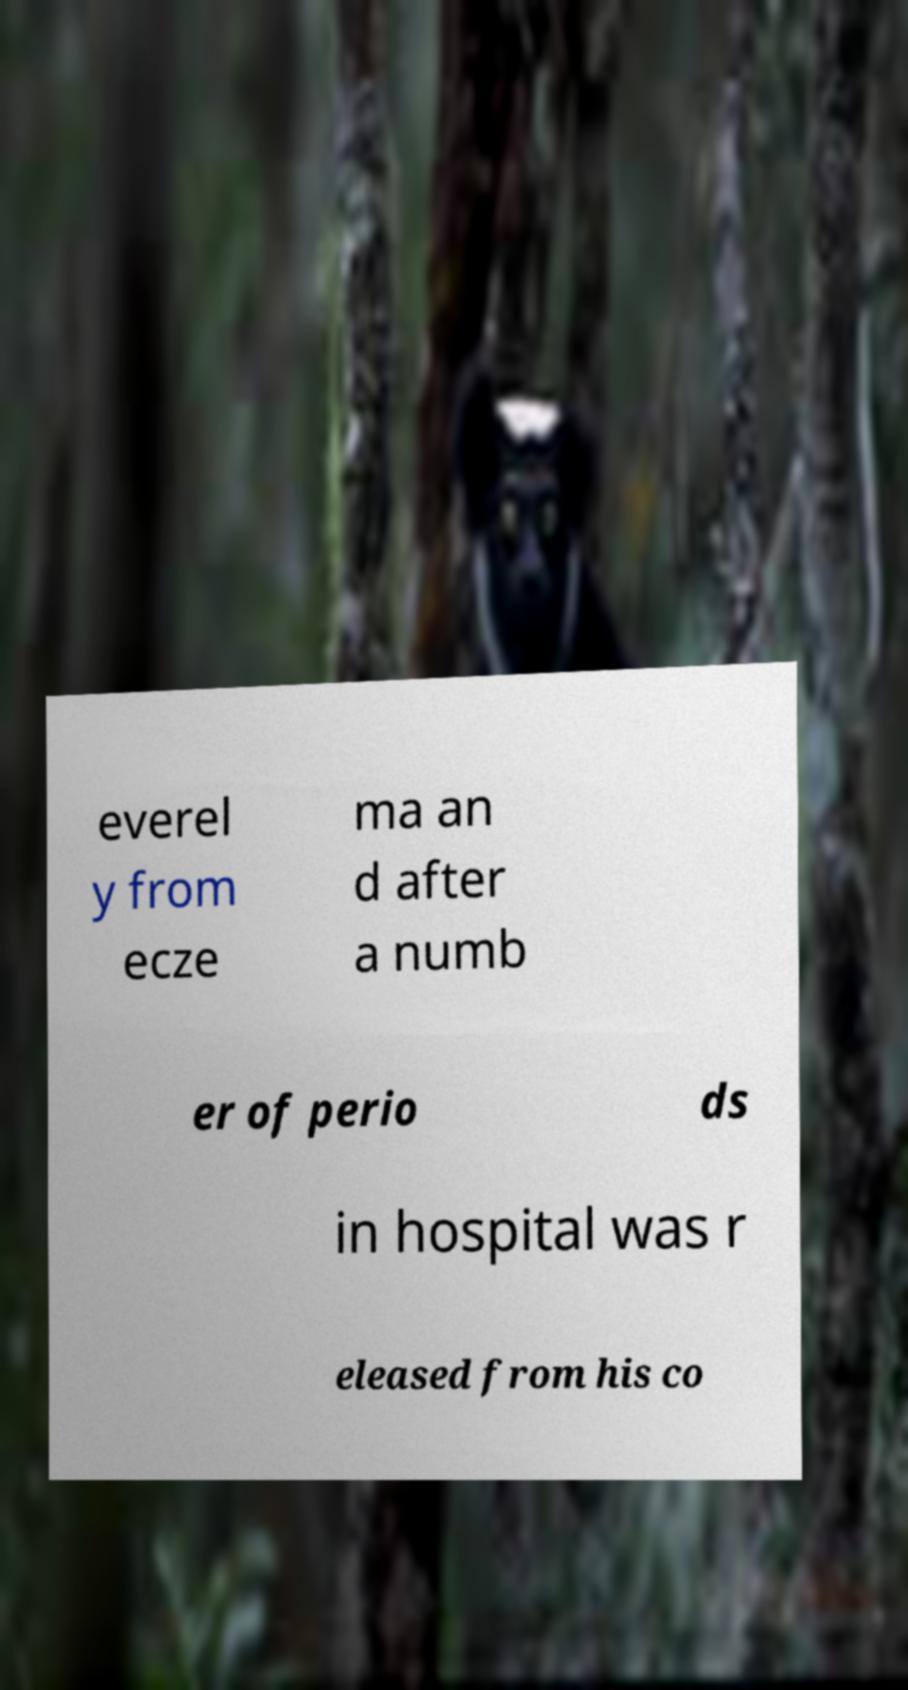Can you read and provide the text displayed in the image?This photo seems to have some interesting text. Can you extract and type it out for me? everel y from ecze ma an d after a numb er of perio ds in hospital was r eleased from his co 